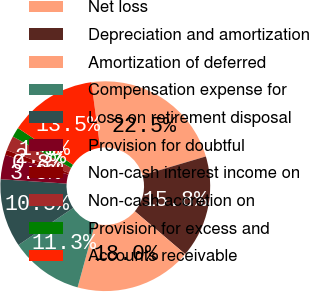Convert chart. <chart><loc_0><loc_0><loc_500><loc_500><pie_chart><fcel>Net loss<fcel>Depreciation and amortization<fcel>Amortization of deferred<fcel>Compensation expense for<fcel>Loss on retirement disposal<fcel>Provision for doubtful<fcel>Non-cash interest income on<fcel>Non-cash accretion on<fcel>Provision for excess and<fcel>Accounts receivable<nl><fcel>22.55%<fcel>15.79%<fcel>18.04%<fcel>11.28%<fcel>10.53%<fcel>3.76%<fcel>0.76%<fcel>2.26%<fcel>1.51%<fcel>13.53%<nl></chart> 